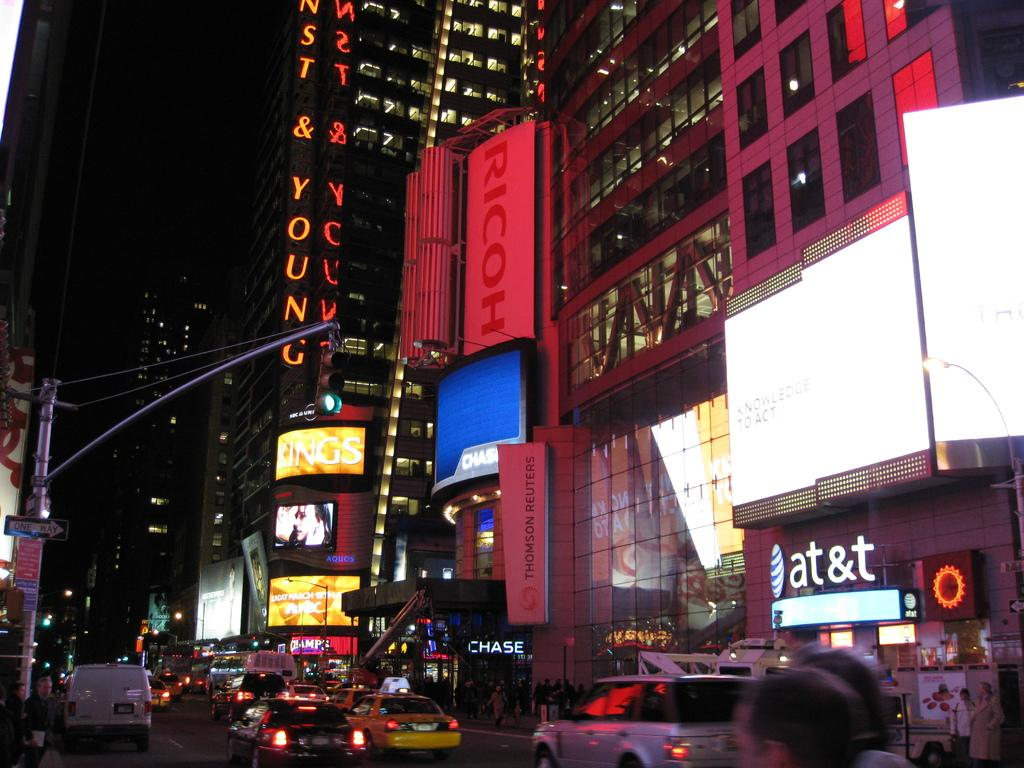<image>
Relay a brief, clear account of the picture shown. Several vehicles are driving down a street and a at&t logo can be seen on the right. 